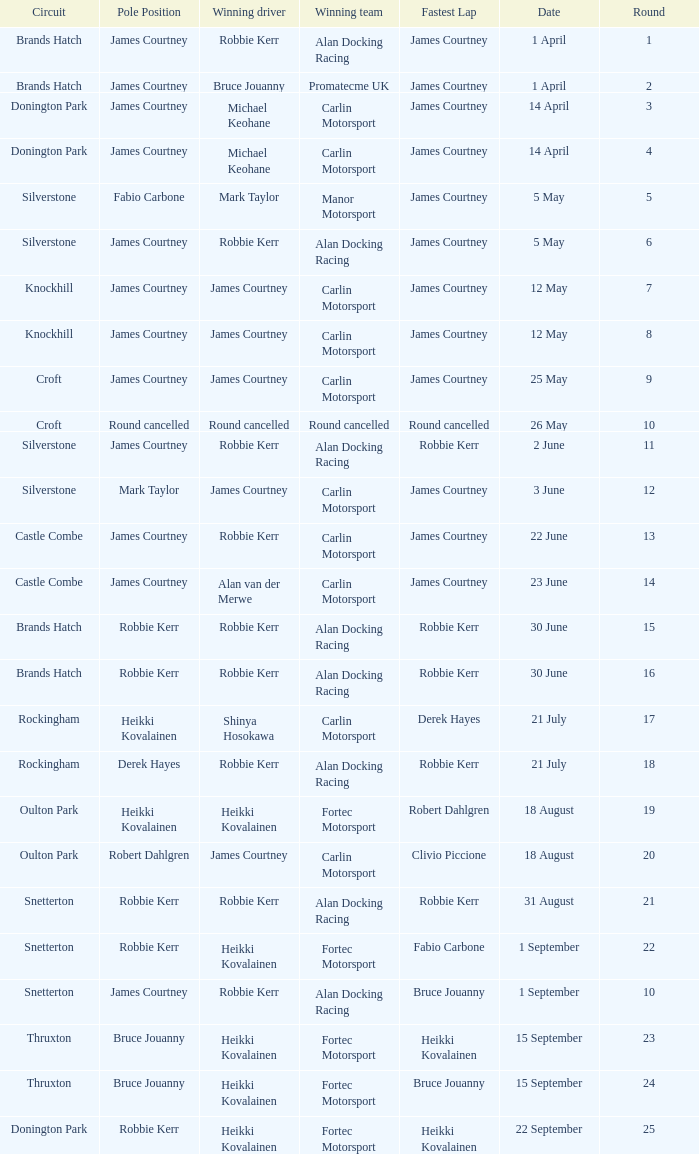How many rounds have Fabio Carbone for fastest lap? 1.0. Would you be able to parse every entry in this table? {'header': ['Circuit', 'Pole Position', 'Winning driver', 'Winning team', 'Fastest Lap', 'Date', 'Round'], 'rows': [['Brands Hatch', 'James Courtney', 'Robbie Kerr', 'Alan Docking Racing', 'James Courtney', '1 April', '1'], ['Brands Hatch', 'James Courtney', 'Bruce Jouanny', 'Promatecme UK', 'James Courtney', '1 April', '2'], ['Donington Park', 'James Courtney', 'Michael Keohane', 'Carlin Motorsport', 'James Courtney', '14 April', '3'], ['Donington Park', 'James Courtney', 'Michael Keohane', 'Carlin Motorsport', 'James Courtney', '14 April', '4'], ['Silverstone', 'Fabio Carbone', 'Mark Taylor', 'Manor Motorsport', 'James Courtney', '5 May', '5'], ['Silverstone', 'James Courtney', 'Robbie Kerr', 'Alan Docking Racing', 'James Courtney', '5 May', '6'], ['Knockhill', 'James Courtney', 'James Courtney', 'Carlin Motorsport', 'James Courtney', '12 May', '7'], ['Knockhill', 'James Courtney', 'James Courtney', 'Carlin Motorsport', 'James Courtney', '12 May', '8'], ['Croft', 'James Courtney', 'James Courtney', 'Carlin Motorsport', 'James Courtney', '25 May', '9'], ['Croft', 'Round cancelled', 'Round cancelled', 'Round cancelled', 'Round cancelled', '26 May', '10'], ['Silverstone', 'James Courtney', 'Robbie Kerr', 'Alan Docking Racing', 'Robbie Kerr', '2 June', '11'], ['Silverstone', 'Mark Taylor', 'James Courtney', 'Carlin Motorsport', 'James Courtney', '3 June', '12'], ['Castle Combe', 'James Courtney', 'Robbie Kerr', 'Carlin Motorsport', 'James Courtney', '22 June', '13'], ['Castle Combe', 'James Courtney', 'Alan van der Merwe', 'Carlin Motorsport', 'James Courtney', '23 June', '14'], ['Brands Hatch', 'Robbie Kerr', 'Robbie Kerr', 'Alan Docking Racing', 'Robbie Kerr', '30 June', '15'], ['Brands Hatch', 'Robbie Kerr', 'Robbie Kerr', 'Alan Docking Racing', 'Robbie Kerr', '30 June', '16'], ['Rockingham', 'Heikki Kovalainen', 'Shinya Hosokawa', 'Carlin Motorsport', 'Derek Hayes', '21 July', '17'], ['Rockingham', 'Derek Hayes', 'Robbie Kerr', 'Alan Docking Racing', 'Robbie Kerr', '21 July', '18'], ['Oulton Park', 'Heikki Kovalainen', 'Heikki Kovalainen', 'Fortec Motorsport', 'Robert Dahlgren', '18 August', '19'], ['Oulton Park', 'Robert Dahlgren', 'James Courtney', 'Carlin Motorsport', 'Clivio Piccione', '18 August', '20'], ['Snetterton', 'Robbie Kerr', 'Robbie Kerr', 'Alan Docking Racing', 'Robbie Kerr', '31 August', '21'], ['Snetterton', 'Robbie Kerr', 'Heikki Kovalainen', 'Fortec Motorsport', 'Fabio Carbone', '1 September', '22'], ['Snetterton', 'James Courtney', 'Robbie Kerr', 'Alan Docking Racing', 'Bruce Jouanny', '1 September', '10'], ['Thruxton', 'Bruce Jouanny', 'Heikki Kovalainen', 'Fortec Motorsport', 'Heikki Kovalainen', '15 September', '23'], ['Thruxton', 'Bruce Jouanny', 'Heikki Kovalainen', 'Fortec Motorsport', 'Bruce Jouanny', '15 September', '24'], ['Donington Park', 'Robbie Kerr', 'Heikki Kovalainen', 'Fortec Motorsport', 'Heikki Kovalainen', '22 September', '25']]} 